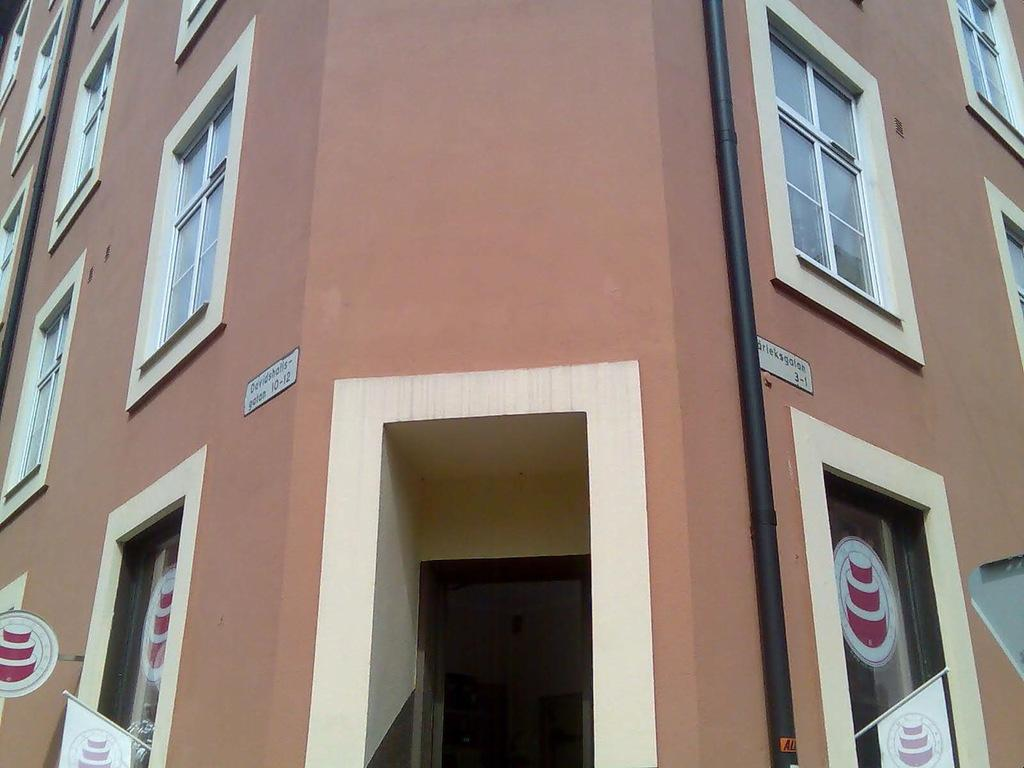What type of structure is visible in the image? There is a building in the image. What features can be seen on the building? The building has doors and windows. What else is present on the right side of the image? There is a pipe on the right side of the image. What type of thumb can be seen on the building in the image? There is no thumb present on the building in the image. What type of blade is being used to cut the building in the image? There is no blade or cutting activity depicted in the image; the building is intact. 